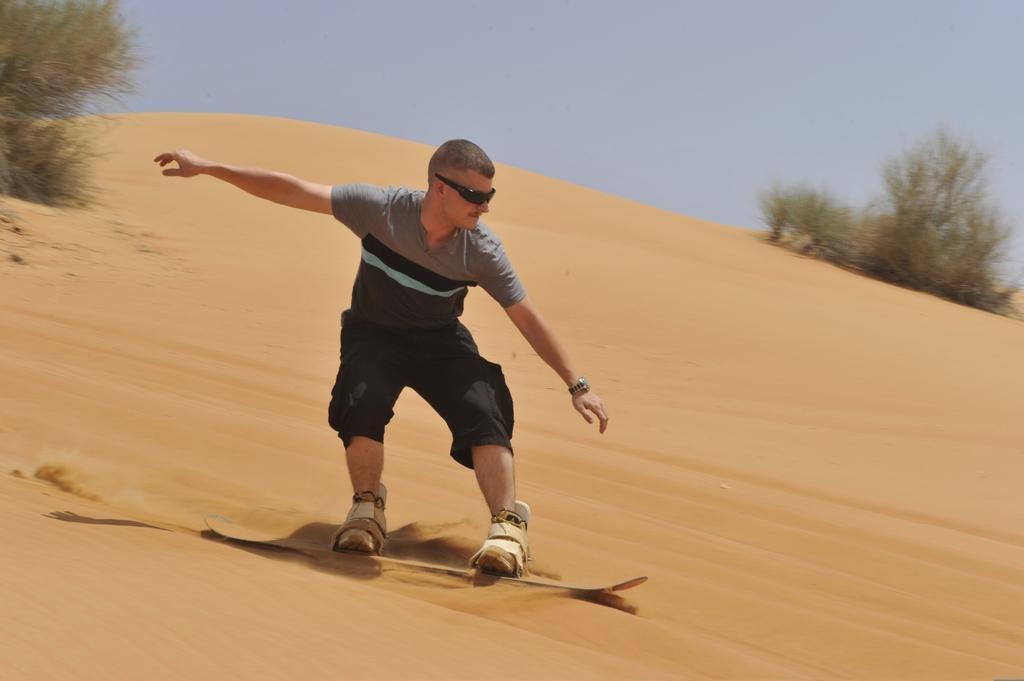Can you describe this image briefly? In this image we can see a person skating on sand. In the background there are plants and sky. 